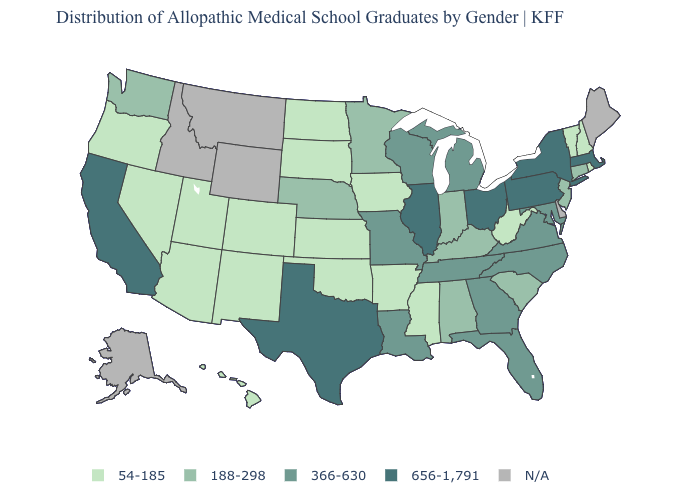Name the states that have a value in the range 366-630?
Keep it brief. Florida, Georgia, Louisiana, Maryland, Michigan, Missouri, North Carolina, Tennessee, Virginia, Wisconsin. Name the states that have a value in the range 188-298?
Give a very brief answer. Alabama, Connecticut, Indiana, Kentucky, Minnesota, Nebraska, New Jersey, South Carolina, Washington. What is the lowest value in the USA?
Be succinct. 54-185. Name the states that have a value in the range 656-1,791?
Give a very brief answer. California, Illinois, Massachusetts, New York, Ohio, Pennsylvania, Texas. Does Mississippi have the lowest value in the South?
Answer briefly. Yes. What is the value of Montana?
Concise answer only. N/A. Name the states that have a value in the range 54-185?
Quick response, please. Arizona, Arkansas, Colorado, Hawaii, Iowa, Kansas, Mississippi, Nevada, New Hampshire, New Mexico, North Dakota, Oklahoma, Oregon, Rhode Island, South Dakota, Utah, Vermont, West Virginia. Name the states that have a value in the range 188-298?
Quick response, please. Alabama, Connecticut, Indiana, Kentucky, Minnesota, Nebraska, New Jersey, South Carolina, Washington. Among the states that border Illinois , which have the highest value?
Keep it brief. Missouri, Wisconsin. Which states have the lowest value in the West?
Quick response, please. Arizona, Colorado, Hawaii, Nevada, New Mexico, Oregon, Utah. Which states hav the highest value in the West?
Keep it brief. California. What is the highest value in the USA?
Quick response, please. 656-1,791. Among the states that border West Virginia , which have the highest value?
Be succinct. Ohio, Pennsylvania. 